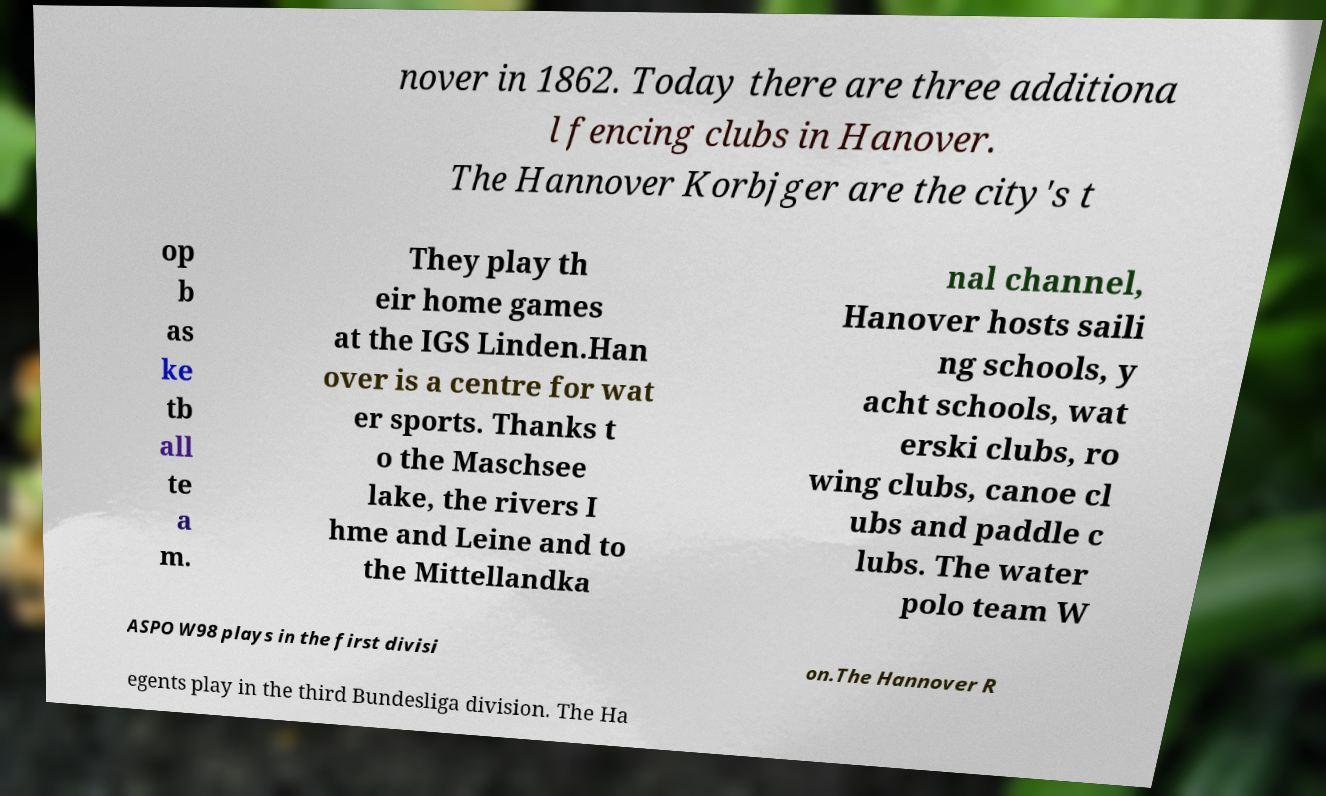Could you extract and type out the text from this image? nover in 1862. Today there are three additiona l fencing clubs in Hanover. The Hannover Korbjger are the city's t op b as ke tb all te a m. They play th eir home games at the IGS Linden.Han over is a centre for wat er sports. Thanks t o the Maschsee lake, the rivers I hme and Leine and to the Mittellandka nal channel, Hanover hosts saili ng schools, y acht schools, wat erski clubs, ro wing clubs, canoe cl ubs and paddle c lubs. The water polo team W ASPO W98 plays in the first divisi on.The Hannover R egents play in the third Bundesliga division. The Ha 